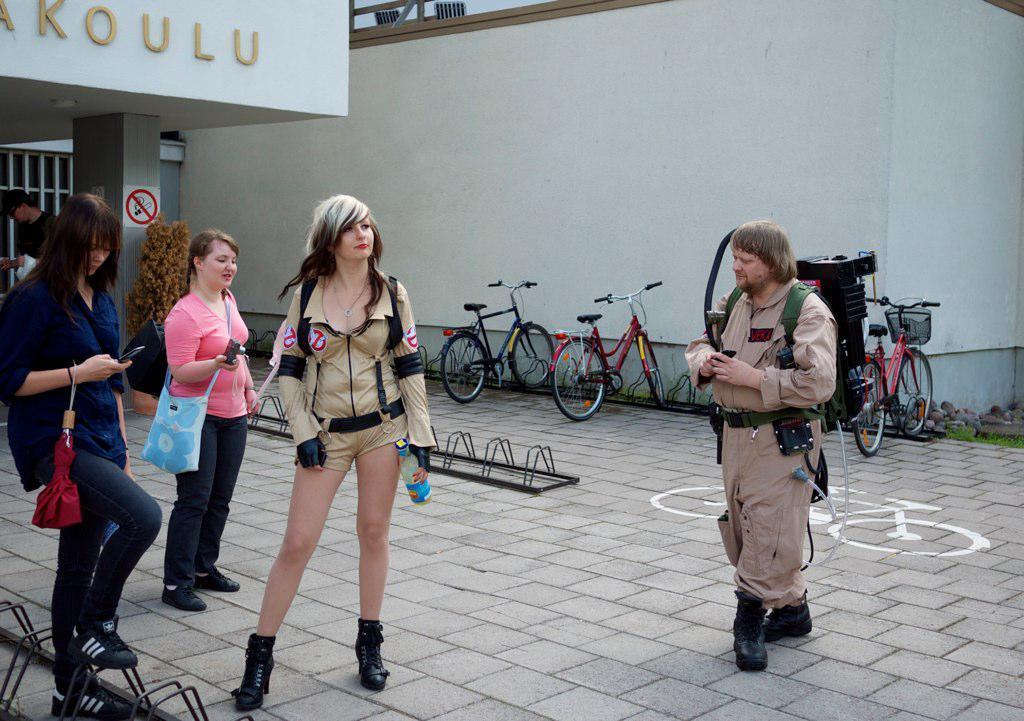Describe this image in one or two sentences. In the middle of the image few people are standing and walking. Behind them there are some bicycles. At the top of the image there is a building. 